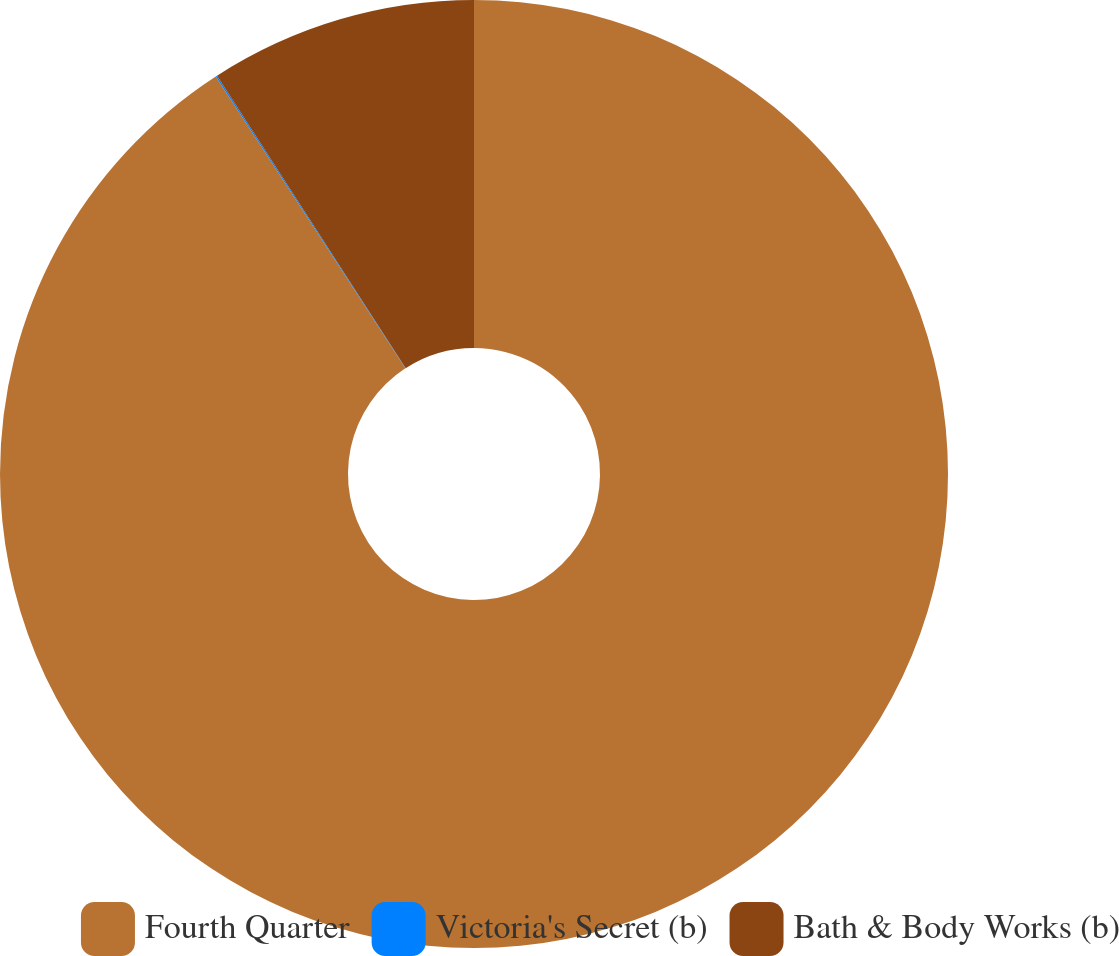Convert chart to OTSL. <chart><loc_0><loc_0><loc_500><loc_500><pie_chart><fcel>Fourth Quarter<fcel>Victoria's Secret (b)<fcel>Bath & Body Works (b)<nl><fcel>90.83%<fcel>0.05%<fcel>9.12%<nl></chart> 